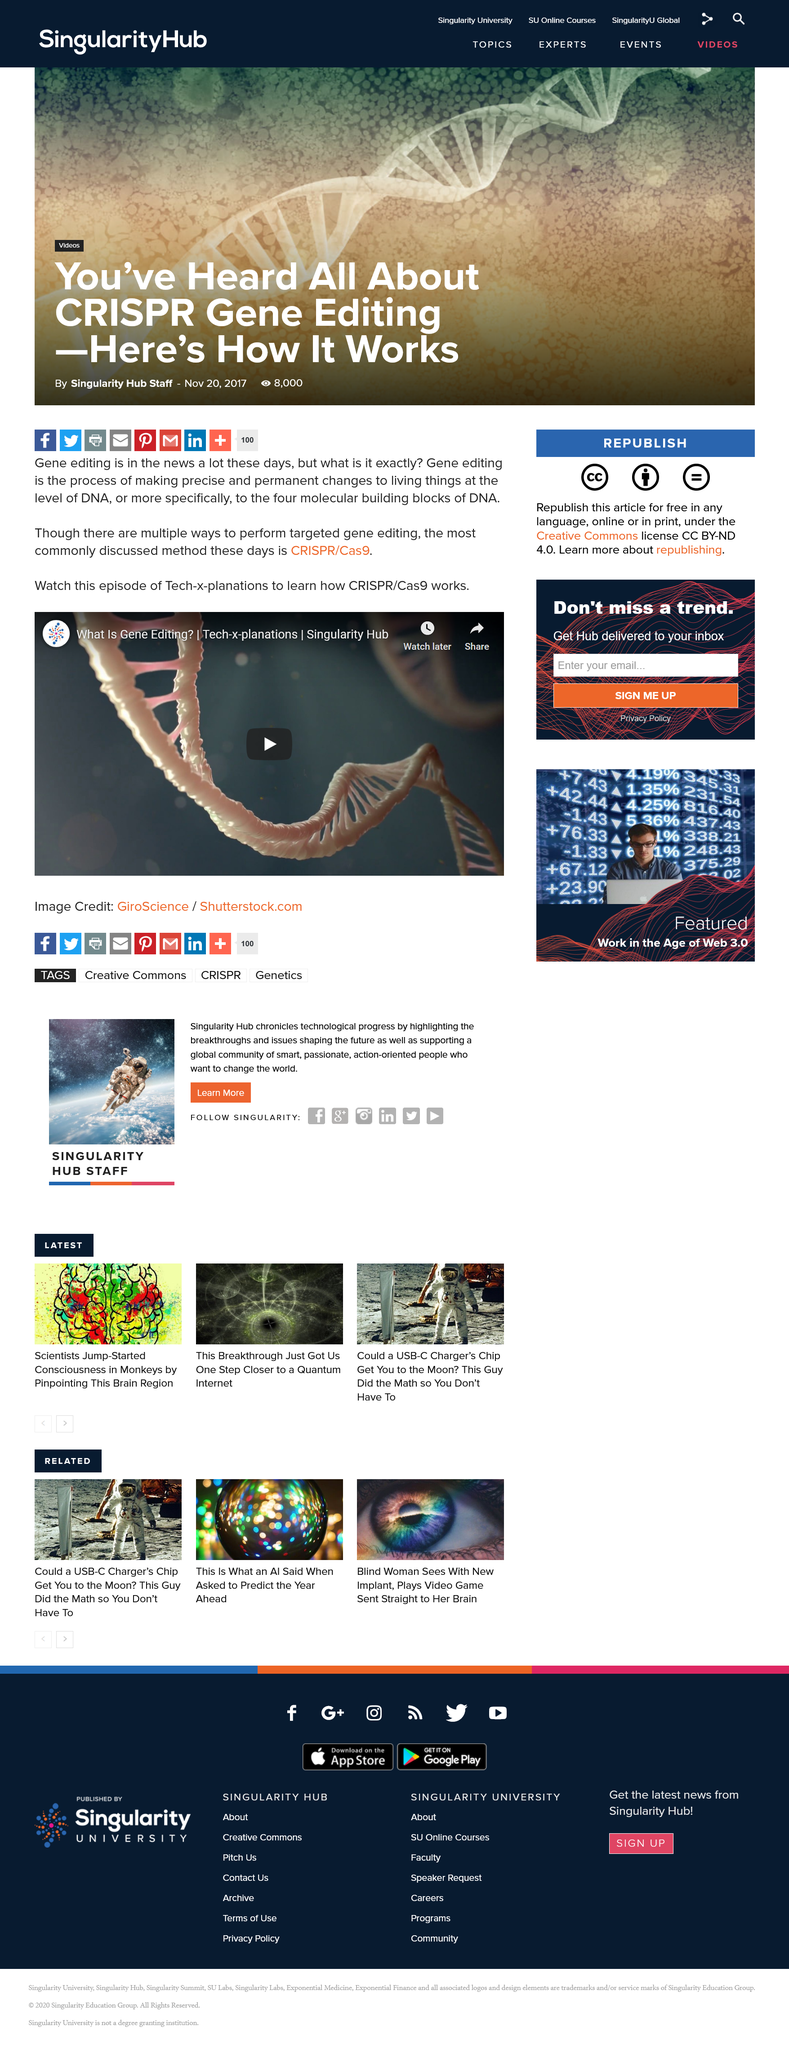Indicate a few pertinent items in this graphic. The most widely used method for targeted gene editing is CRISPR/Cas9. There are four molecular building blocks in DNA. Gene editing is the process of making specific and long-lasting modifications to living organisms by altering their DNA. 